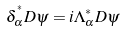Convert formula to latex. <formula><loc_0><loc_0><loc_500><loc_500>\delta _ { \alpha } ^ { ^ { * } } D \psi = i \Lambda _ { \alpha } ^ { * } D \psi</formula> 